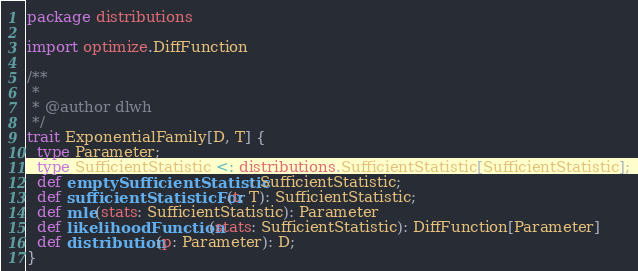Convert code to text. <code><loc_0><loc_0><loc_500><loc_500><_Scala_>package distributions

import optimize.DiffFunction

/**
 *
 * @author dlwh
 */
trait ExponentialFamily[D, T] {
  type Parameter;
  type SufficientStatistic <: distributions.SufficientStatistic[SufficientStatistic];
  def emptySufficientStatistic: SufficientStatistic;
  def sufficientStatisticFor(t: T): SufficientStatistic;
  def mle(stats: SufficientStatistic): Parameter
  def likelihoodFunction(stats: SufficientStatistic): DiffFunction[Parameter]
  def distribution(p: Parameter): D;
}
</code> 